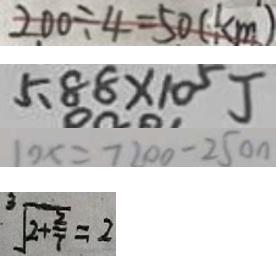<formula> <loc_0><loc_0><loc_500><loc_500>2 0 0 \div 4 = 5 0 ( k m ) 
 5 . 8 8 \times 1 0 ^ { 5 } J 
 1 0 x = 7 2 0 0 - 2 5 0 0 
 \sqrt [ 3 ] { 2 + \frac { 2 } { 7 } } = 2</formula> 